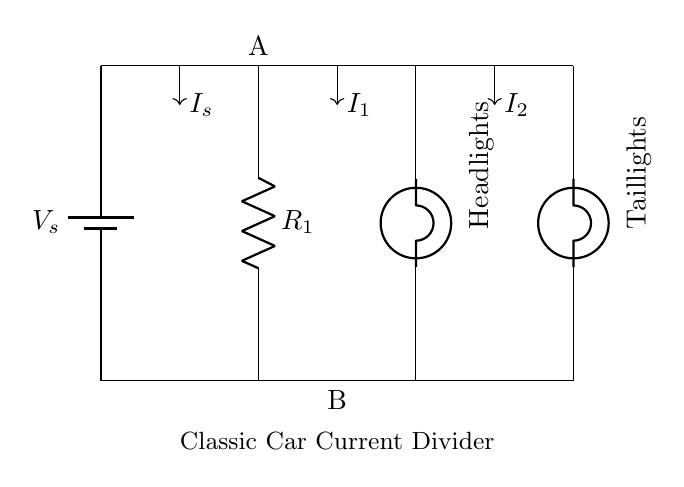What is the type of circuit shown? The circuit is a parallel circuit, as evidenced by multiple components connected directly to the same voltage source without a series connection.
Answer: Parallel circuit What are the components connected in this circuit? The components include a battery, a resistor, a bulb for headlights, and a bulb for taillights. Each of these elements has a functional role in the circuit.
Answer: Battery, resistor, headlights bulb, taillights bulb What is the purpose of the resistor in this circuit? The resistor limits the current flowing through the circuit, which can help in adjusting the brightness of the headlights compared to the taillights.
Answer: Current limiting How does current split between the headlights and taillights? The current splits according to the resistance of the bulbs; more current goes through the component with lower resistance. This follows Ohm's Law, where current is inversely proportional to resistance.
Answer: According to resistance What does the symbol on the left represent? The left symbol represents a battery, which provides the voltage to power the circuit and drive the flow of current.
Answer: Battery Which direction does the total current flow in this circuit? The total current flows from the battery, through the circuit branches to the bulbs, and returns back to the battery, following the path of least resistance.
Answer: Clockwise 